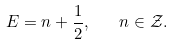Convert formula to latex. <formula><loc_0><loc_0><loc_500><loc_500>E = n + \frac { 1 } { 2 } , \quad n \in \mathcal { Z } .</formula> 